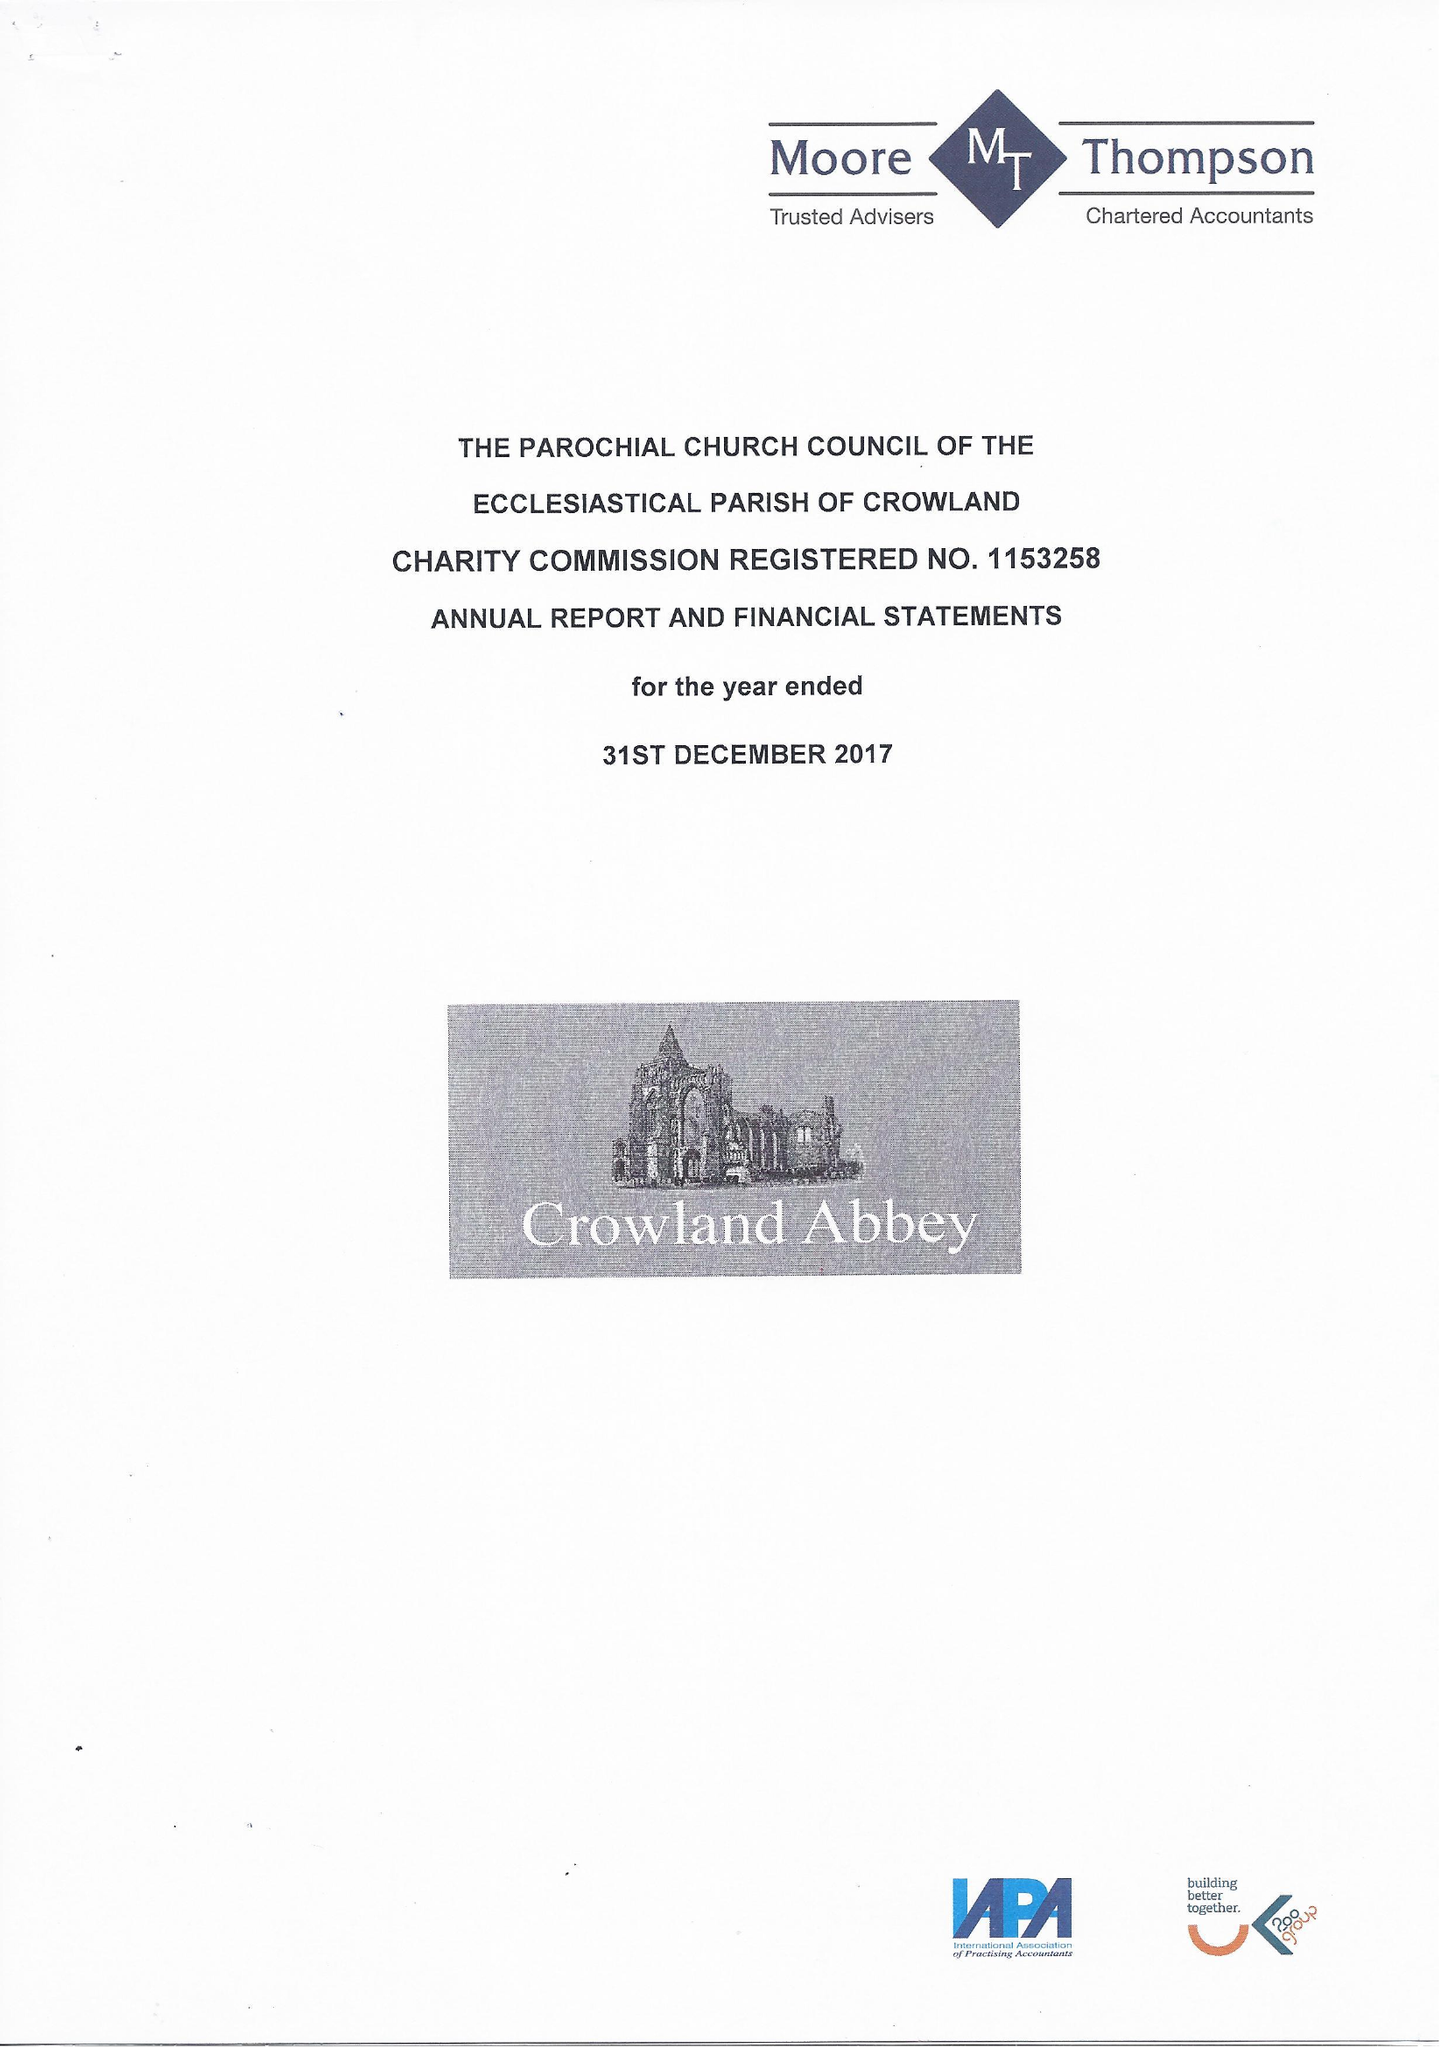What is the value for the income_annually_in_british_pounds?
Answer the question using a single word or phrase. 80062.00 